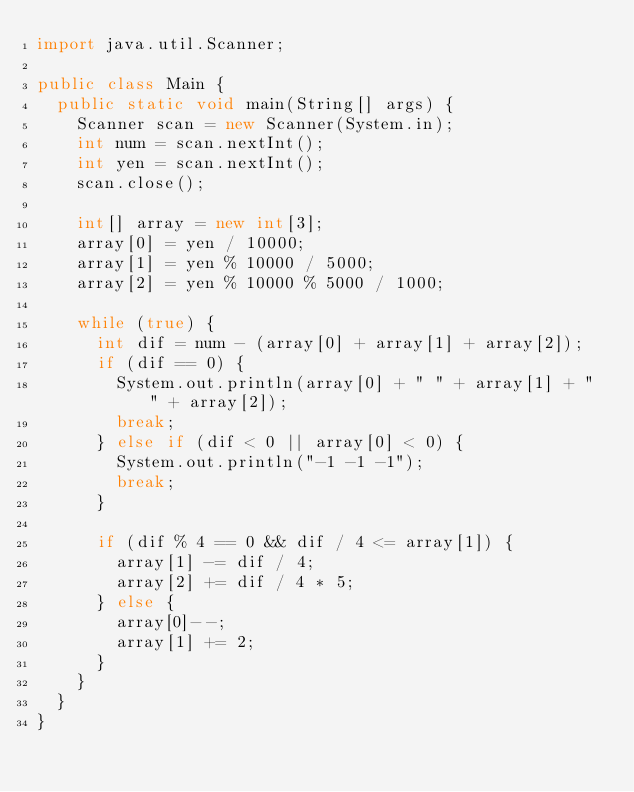<code> <loc_0><loc_0><loc_500><loc_500><_Java_>import java.util.Scanner;

public class Main {
	public static void main(String[] args) {
		Scanner scan = new Scanner(System.in);
		int num = scan.nextInt();
		int yen = scan.nextInt();
		scan.close();
		
		int[] array = new int[3];
		array[0] = yen / 10000;
		array[1] = yen % 10000 / 5000;
		array[2] = yen % 10000 % 5000 / 1000;

		while (true) {
			int dif = num - (array[0] + array[1] + array[2]);
			if (dif == 0) {
				System.out.println(array[0] + " " + array[1] + " " + array[2]);
				break;
			} else if (dif < 0 || array[0] < 0) {
				System.out.println("-1 -1 -1");
				break;
			}

			if (dif % 4 == 0 && dif / 4 <= array[1]) {
				array[1] -= dif / 4;
				array[2] += dif / 4 * 5;
			} else {
				array[0]--;
				array[1] += 2;
			}
		}
	}
}
</code> 